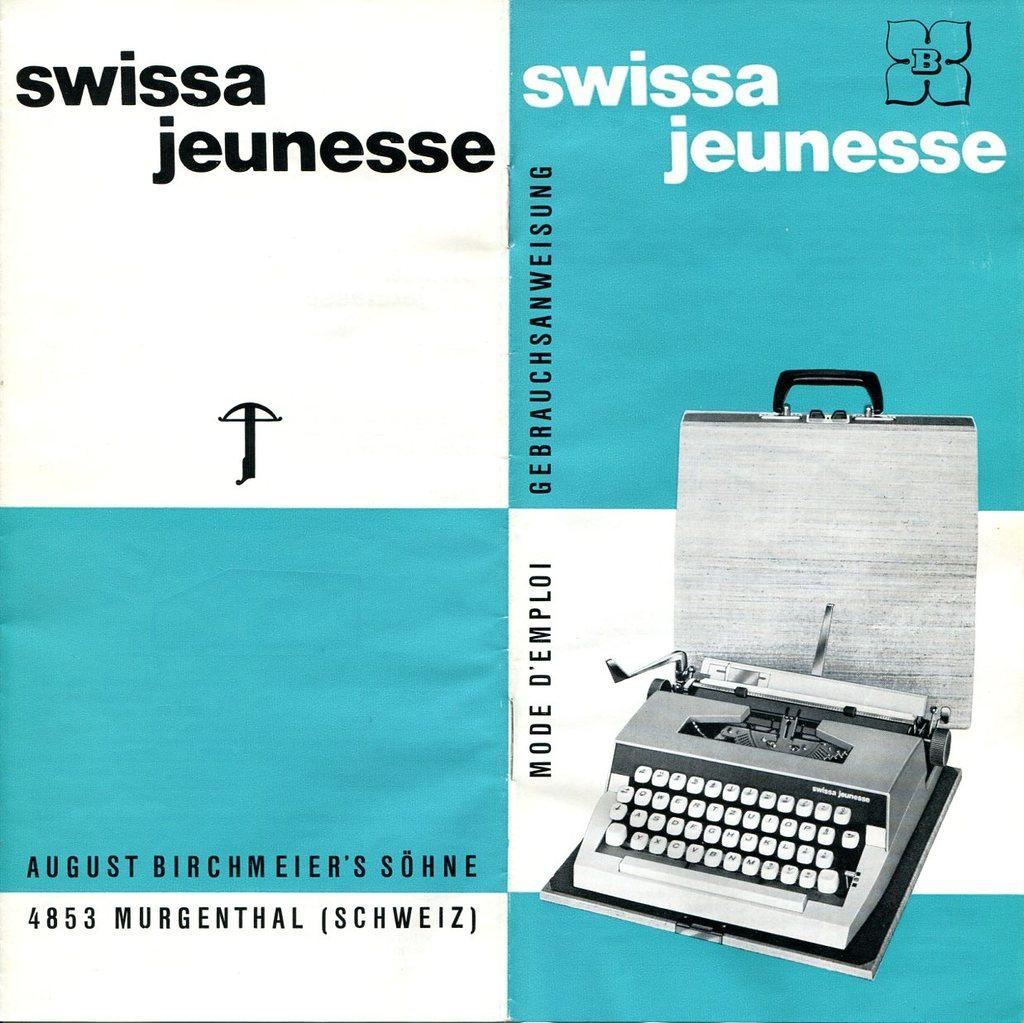<image>
Describe the image concisely. an advertisement for a typewriter brand swissa jeunesse 